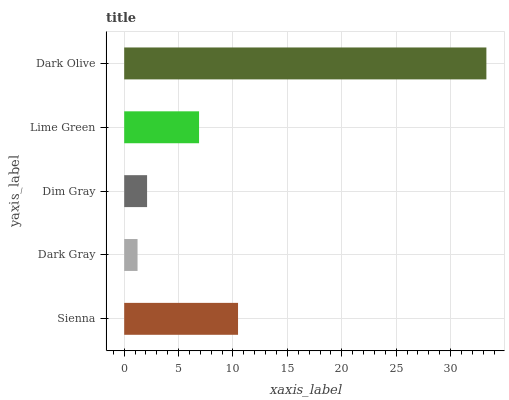Is Dark Gray the minimum?
Answer yes or no. Yes. Is Dark Olive the maximum?
Answer yes or no. Yes. Is Dim Gray the minimum?
Answer yes or no. No. Is Dim Gray the maximum?
Answer yes or no. No. Is Dim Gray greater than Dark Gray?
Answer yes or no. Yes. Is Dark Gray less than Dim Gray?
Answer yes or no. Yes. Is Dark Gray greater than Dim Gray?
Answer yes or no. No. Is Dim Gray less than Dark Gray?
Answer yes or no. No. Is Lime Green the high median?
Answer yes or no. Yes. Is Lime Green the low median?
Answer yes or no. Yes. Is Dark Gray the high median?
Answer yes or no. No. Is Dim Gray the low median?
Answer yes or no. No. 